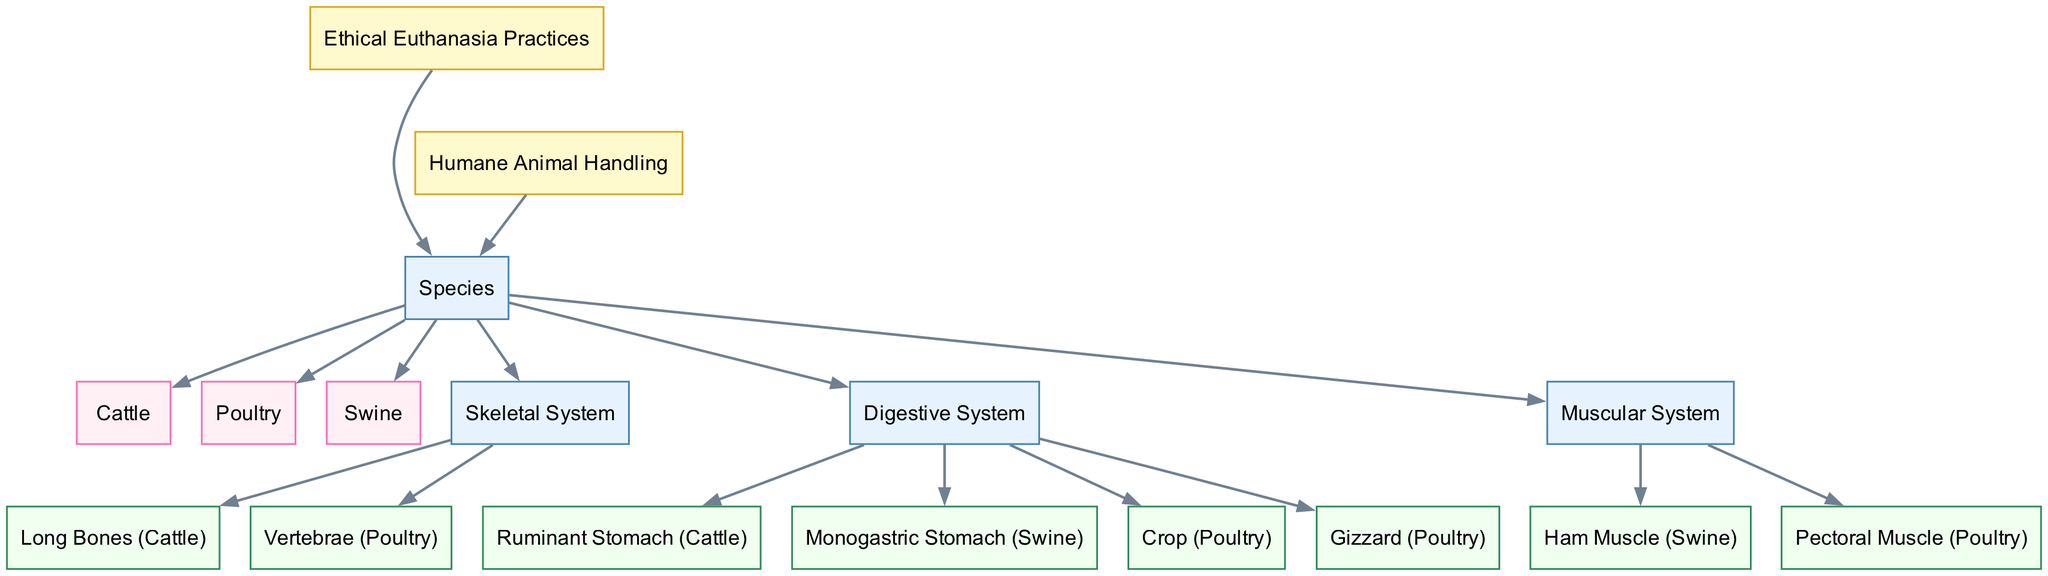What species has a ruminant stomach? The diagram shows that the ruminant stomach feature is linked specifically to cattle, indicating it is unique to this species among the ones depicted.
Answer: Ruminant Stomach (Cattle) How many species are represented in the diagram? By counting the nodes categorized under 'species', we find cattle, poultry, and swine, totaling three distinct species.
Answer: 3 Which skeletal feature is associated with poultry? The diagram connects the vertebrae as the specific skeletal feature associated with poultry, highlighting this as a notable point.
Answer: Vertebrae (Poultry) What type of stomach does swine have? The diagram reveals that swine possesses a monogastric stomach, distinct from the ruminant stomach of cattle.
Answer: Monogastric Stomach (Swine) Which muscular feature is identified for poultry? The diagram indicates that the pectoral muscle is the muscular feature specifically identified for poultry, underscoring its importance for the species.
Answer: Pectoral Muscle (Poultry) Which practices are connected to all species in the diagram? Both ethical euthanasia practices and humane animal handling practices are indicated to be connected to all three species, reinforcing the ethical considerations across farm animals.
Answer: Ethical Euthanasia Practices, Humane Animal Handling Which type of digestive system is represented for cattle? The digestive system type for cattle, as shown in the diagram, is characterized as having a ruminant stomach, distinguishing it from the other species listed.
Answer: Ruminant Stomach (Cattle) Which species has long bones in the skeletal system? The diagram highlights that long bones are a specific feature of the skeletal system pertaining to cattle, setting it apart from poultry and swine.
Answer: Long Bones (Cattle) What is the color of the nodes representing species? The nodes portraying species are filled with a light pink color, which visually differentiates them from other categories in the diagram.
Answer: Light Pink 